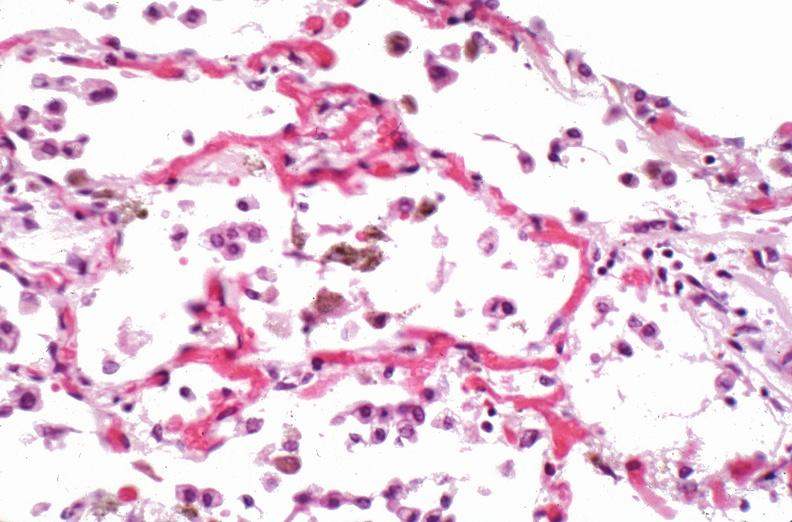what is present?
Answer the question using a single word or phrase. Respiratory 